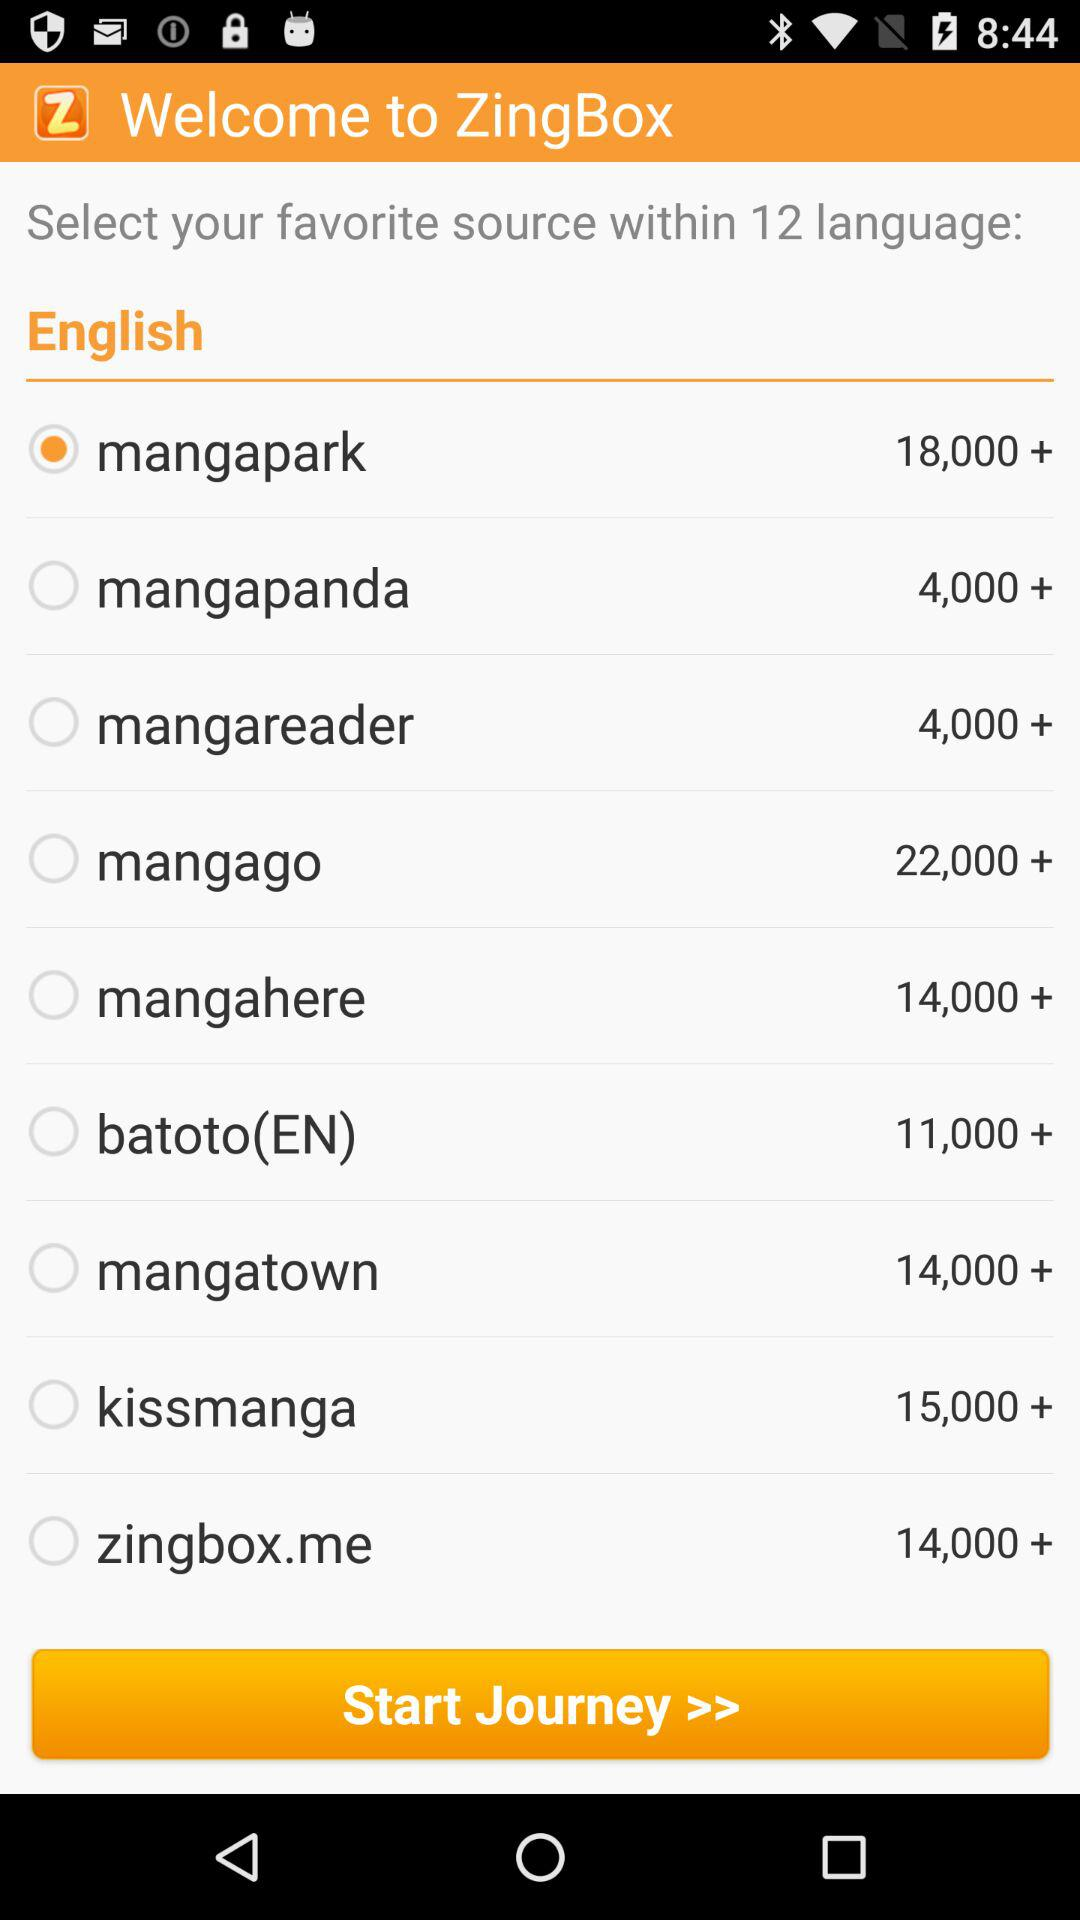Which option is selected? The selected option is "mangapark". 